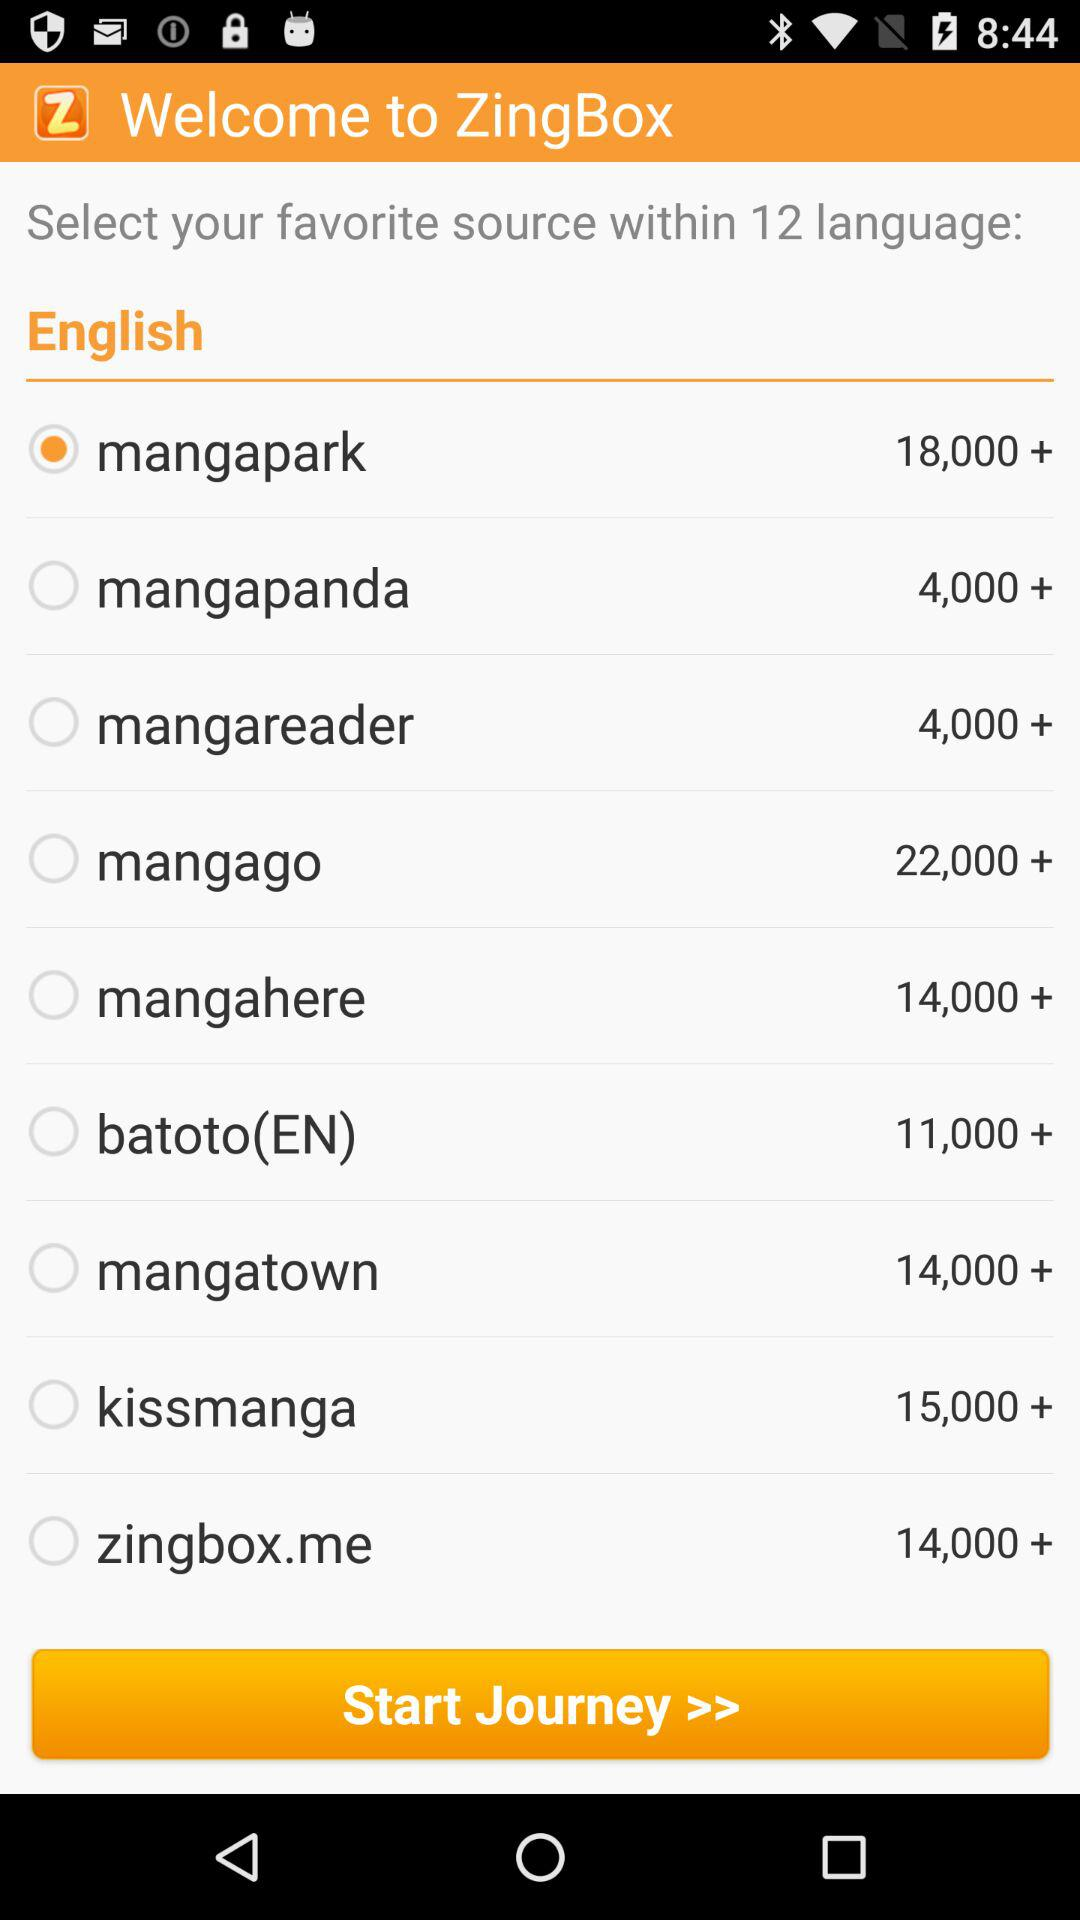Which option is selected? The selected option is "mangapark". 